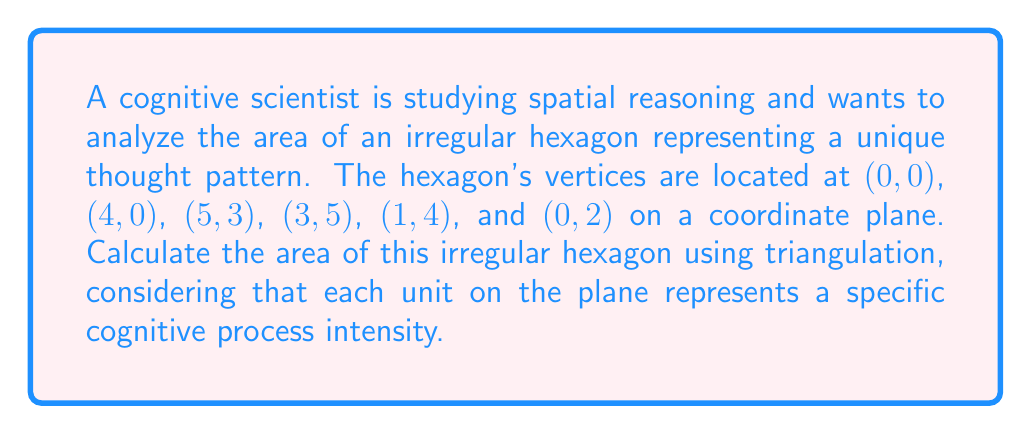What is the answer to this math problem? Let's approach this step-by-step using triangulation:

1. Divide the hexagon into four triangles:
   T1: (0,0), (4,0), (0,2)
   T2: (4,0), (5,3), (3,5)
   T3: (0,0), (3,5), (1,4)
   T4: (0,0), (1,4), (0,2)

2. Calculate the area of each triangle using the formula:
   $$ A = \frac{1}{2}|x_1(y_2 - y_3) + x_2(y_3 - y_1) + x_3(y_1 - y_2)| $$

3. For T1:
   $$ A_1 = \frac{1}{2}|0(0 - 2) + 4(2 - 0) + 0(0 - 0)| = 4 $$

4. For T2:
   $$ A_2 = \frac{1}{2}|4(3 - 5) + 5(5 - 0) + 3(0 - 3)| = 9.5 $$

5. For T3:
   $$ A_3 = \frac{1}{2}|0(5 - 4) + 3(4 - 0) + 1(0 - 5)| = 7 $$

6. For T4:
   $$ A_4 = \frac{1}{2}|0(4 - 2) + 1(2 - 0) + 0(0 - 4)| = 1 $$

7. Sum up all the areas:
   $$ A_{total} = A_1 + A_2 + A_3 + A_4 = 4 + 9.5 + 7 + 1 = 21.5 $$

Therefore, the total area of the irregular hexagon is 21.5 square units.

[asy]
unitsize(20);
draw((0,0)--(4,0)--(5,3)--(3,5)--(1,4)--(0,2)--cycle);
draw((0,0)--(4,0)--(0,2));
draw((4,0)--(3,5));
draw((0,0)--(3,5));
draw((0,0)--(1,4));
label("(0,0)", (0,0), SW);
label("(4,0)", (4,0), SE);
label("(5,3)", (5,3), E);
label("(3,5)", (3,5), N);
label("(1,4)", (1,4), NW);
label("(0,2)", (0,2), W);
[/asy]
Answer: 21.5 square units 